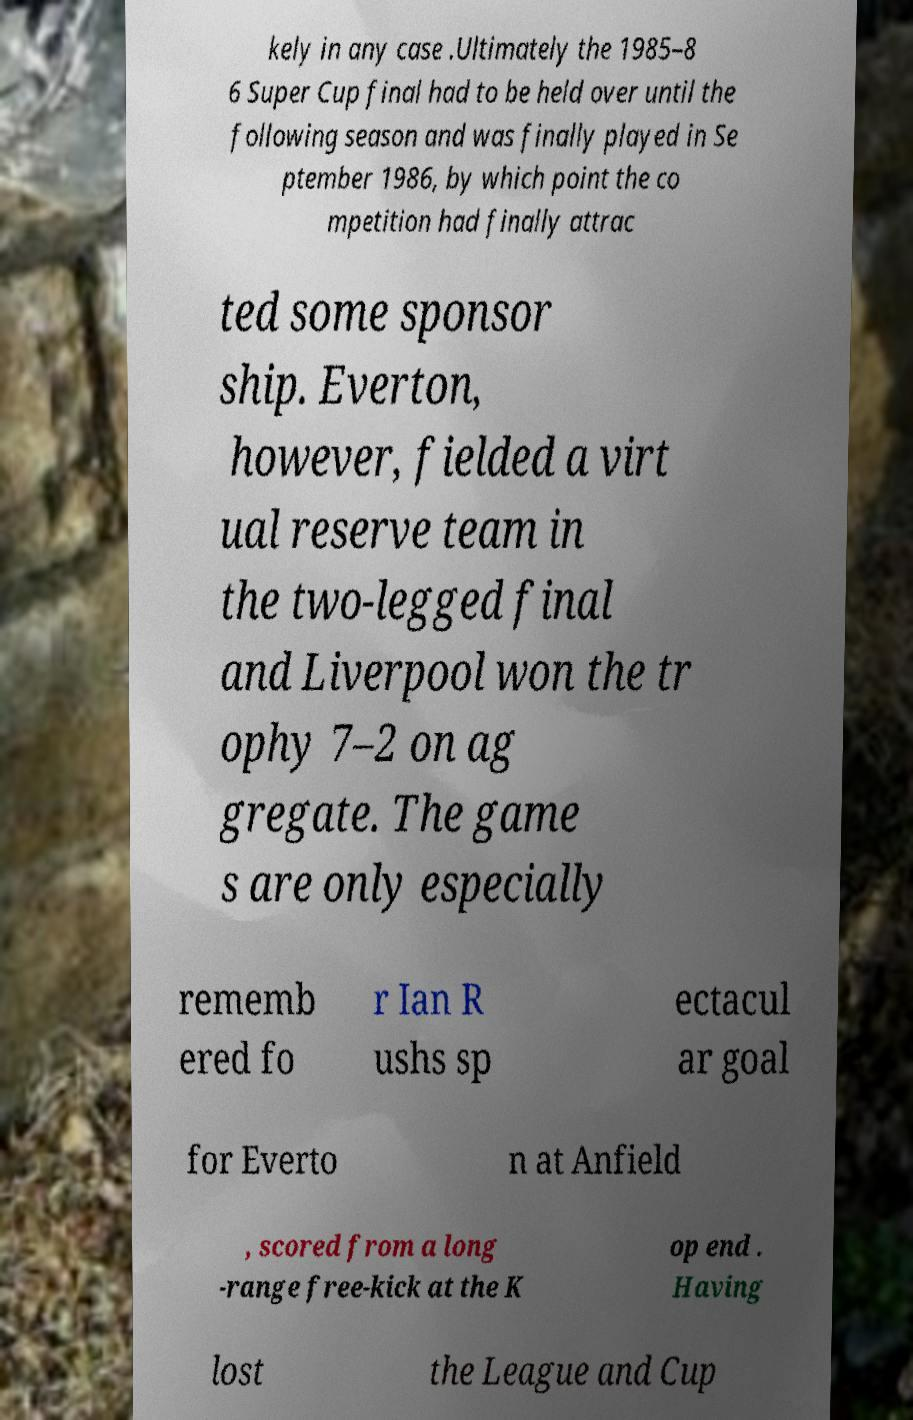There's text embedded in this image that I need extracted. Can you transcribe it verbatim? kely in any case .Ultimately the 1985–8 6 Super Cup final had to be held over until the following season and was finally played in Se ptember 1986, by which point the co mpetition had finally attrac ted some sponsor ship. Everton, however, fielded a virt ual reserve team in the two-legged final and Liverpool won the tr ophy 7–2 on ag gregate. The game s are only especially rememb ered fo r Ian R ushs sp ectacul ar goal for Everto n at Anfield , scored from a long -range free-kick at the K op end . Having lost the League and Cup 